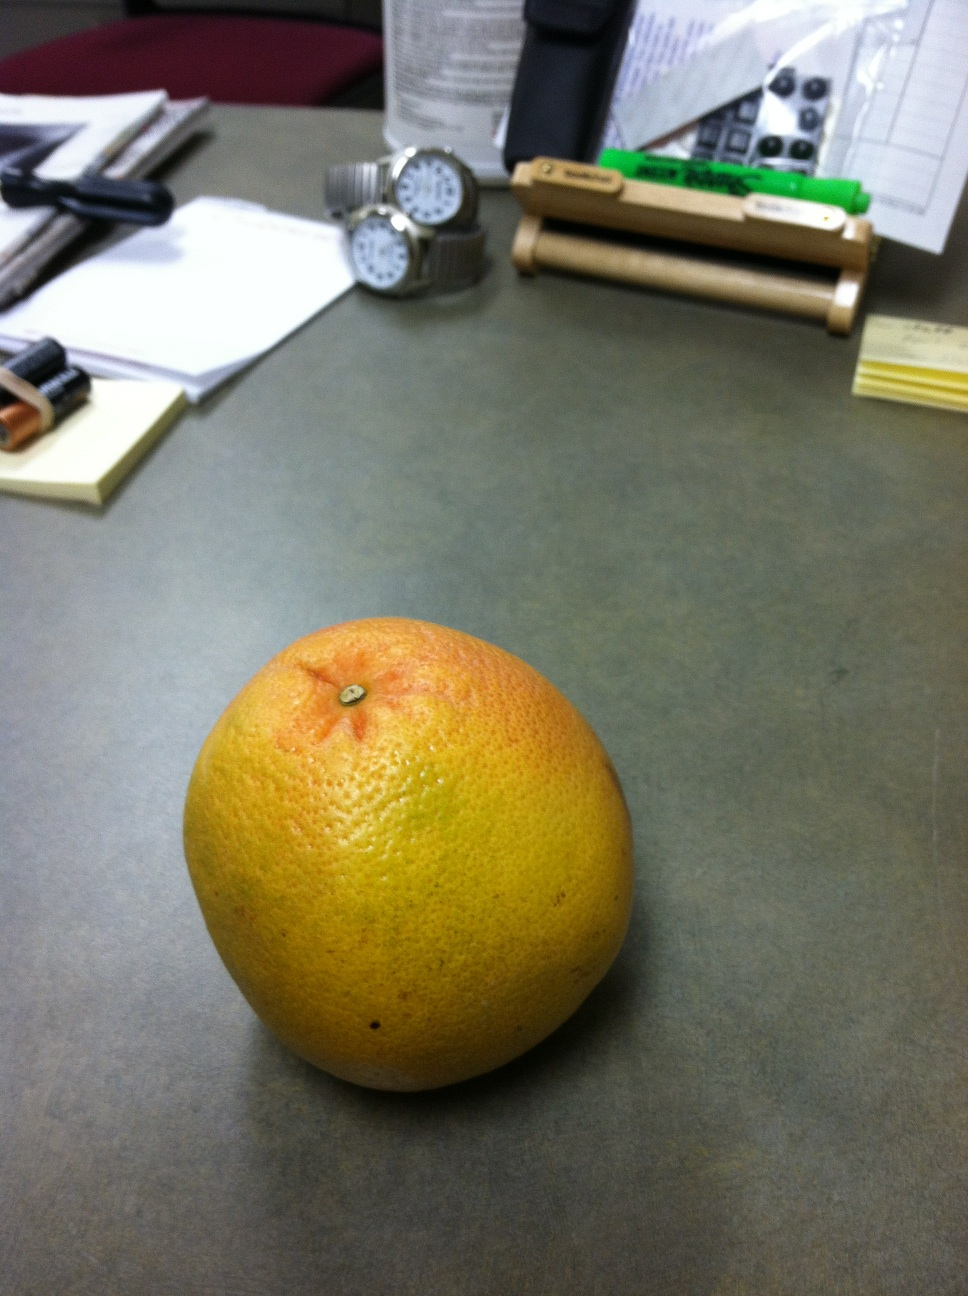Can you imagine what kind of tasks a person might be working on given the items on the desk? Given the items on the desk, it seems plausible that the person may be working on tasks that require both creativity and organization. For instance, the presence of papers and a pen suggests they might be working on reports, drafts, or brainstorming ideas for a project. The watches might indicate they need to be mindful of deadlines or schedules, perhaps juggling meetings or timed tasks. Batteries could suggest that they are working with electronic devices, possibly testing or using gadgets that need frequent power. The grapefruit hints at health-conscious habits, so perhaps the person schedules in breaks for healthy snacks as they work through their tasks. All in all, the desk setup suggests a multifaceted role that combines planning, execution, and a bit of personal care. 